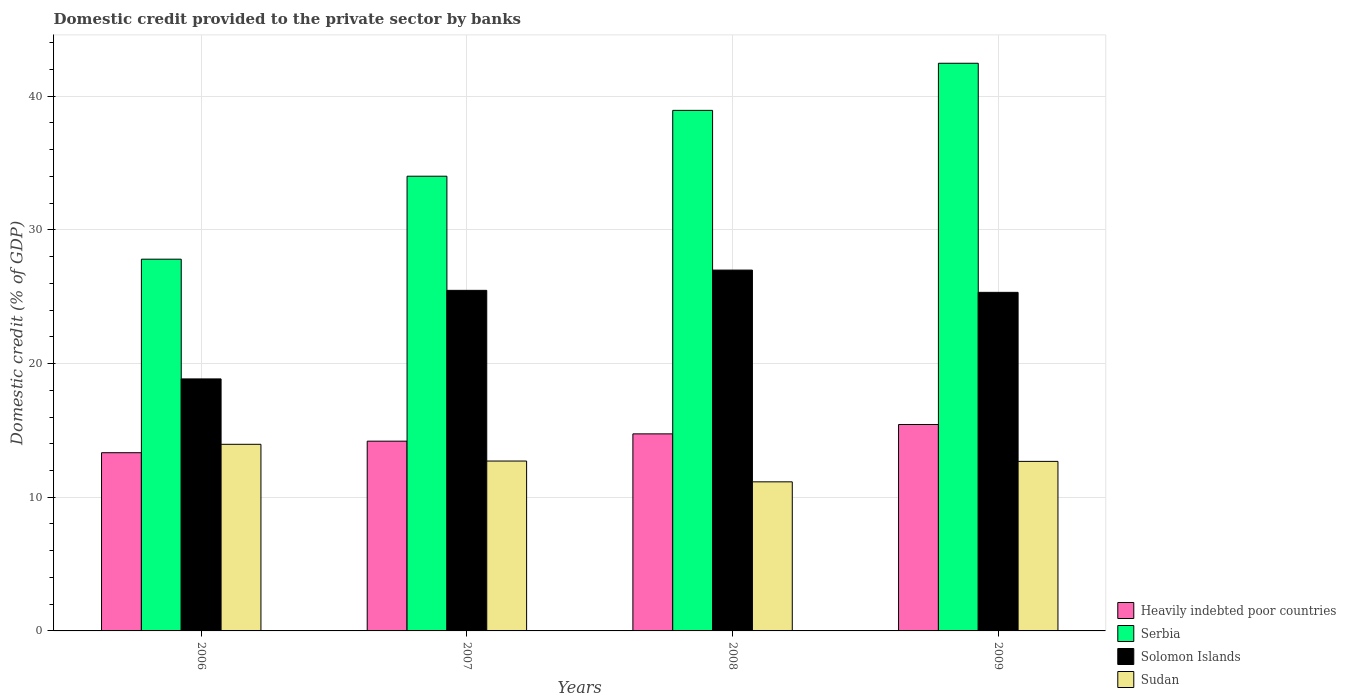How many groups of bars are there?
Provide a succinct answer. 4. How many bars are there on the 1st tick from the left?
Ensure brevity in your answer.  4. What is the label of the 2nd group of bars from the left?
Your answer should be very brief. 2007. In how many cases, is the number of bars for a given year not equal to the number of legend labels?
Provide a short and direct response. 0. What is the domestic credit provided to the private sector by banks in Serbia in 2006?
Ensure brevity in your answer.  27.81. Across all years, what is the maximum domestic credit provided to the private sector by banks in Sudan?
Keep it short and to the point. 13.96. Across all years, what is the minimum domestic credit provided to the private sector by banks in Sudan?
Make the answer very short. 11.15. In which year was the domestic credit provided to the private sector by banks in Serbia minimum?
Give a very brief answer. 2006. What is the total domestic credit provided to the private sector by banks in Sudan in the graph?
Ensure brevity in your answer.  50.5. What is the difference between the domestic credit provided to the private sector by banks in Heavily indebted poor countries in 2006 and that in 2008?
Provide a succinct answer. -1.41. What is the difference between the domestic credit provided to the private sector by banks in Sudan in 2008 and the domestic credit provided to the private sector by banks in Solomon Islands in 2009?
Give a very brief answer. -14.17. What is the average domestic credit provided to the private sector by banks in Heavily indebted poor countries per year?
Make the answer very short. 14.43. In the year 2009, what is the difference between the domestic credit provided to the private sector by banks in Solomon Islands and domestic credit provided to the private sector by banks in Heavily indebted poor countries?
Offer a very short reply. 9.89. In how many years, is the domestic credit provided to the private sector by banks in Serbia greater than 10 %?
Give a very brief answer. 4. What is the ratio of the domestic credit provided to the private sector by banks in Solomon Islands in 2006 to that in 2007?
Offer a terse response. 0.74. Is the difference between the domestic credit provided to the private sector by banks in Solomon Islands in 2006 and 2008 greater than the difference between the domestic credit provided to the private sector by banks in Heavily indebted poor countries in 2006 and 2008?
Give a very brief answer. No. What is the difference between the highest and the second highest domestic credit provided to the private sector by banks in Solomon Islands?
Provide a short and direct response. 1.52. What is the difference between the highest and the lowest domestic credit provided to the private sector by banks in Serbia?
Your response must be concise. 14.66. What does the 1st bar from the left in 2009 represents?
Offer a terse response. Heavily indebted poor countries. What does the 4th bar from the right in 2009 represents?
Offer a very short reply. Heavily indebted poor countries. How many bars are there?
Your answer should be compact. 16. Are all the bars in the graph horizontal?
Ensure brevity in your answer.  No. How many years are there in the graph?
Your response must be concise. 4. Are the values on the major ticks of Y-axis written in scientific E-notation?
Ensure brevity in your answer.  No. Does the graph contain grids?
Offer a very short reply. Yes. Where does the legend appear in the graph?
Offer a terse response. Bottom right. How are the legend labels stacked?
Your response must be concise. Vertical. What is the title of the graph?
Keep it short and to the point. Domestic credit provided to the private sector by banks. Does "Estonia" appear as one of the legend labels in the graph?
Give a very brief answer. No. What is the label or title of the Y-axis?
Provide a succinct answer. Domestic credit (% of GDP). What is the Domestic credit (% of GDP) in Heavily indebted poor countries in 2006?
Provide a succinct answer. 13.33. What is the Domestic credit (% of GDP) in Serbia in 2006?
Give a very brief answer. 27.81. What is the Domestic credit (% of GDP) of Solomon Islands in 2006?
Make the answer very short. 18.85. What is the Domestic credit (% of GDP) of Sudan in 2006?
Make the answer very short. 13.96. What is the Domestic credit (% of GDP) in Heavily indebted poor countries in 2007?
Offer a very short reply. 14.19. What is the Domestic credit (% of GDP) in Serbia in 2007?
Keep it short and to the point. 34.01. What is the Domestic credit (% of GDP) in Solomon Islands in 2007?
Make the answer very short. 25.48. What is the Domestic credit (% of GDP) of Sudan in 2007?
Keep it short and to the point. 12.71. What is the Domestic credit (% of GDP) of Heavily indebted poor countries in 2008?
Keep it short and to the point. 14.74. What is the Domestic credit (% of GDP) in Serbia in 2008?
Your response must be concise. 38.94. What is the Domestic credit (% of GDP) in Solomon Islands in 2008?
Ensure brevity in your answer.  26.99. What is the Domestic credit (% of GDP) in Sudan in 2008?
Your answer should be very brief. 11.15. What is the Domestic credit (% of GDP) of Heavily indebted poor countries in 2009?
Your response must be concise. 15.44. What is the Domestic credit (% of GDP) in Serbia in 2009?
Give a very brief answer. 42.46. What is the Domestic credit (% of GDP) of Solomon Islands in 2009?
Provide a short and direct response. 25.33. What is the Domestic credit (% of GDP) in Sudan in 2009?
Your answer should be very brief. 12.68. Across all years, what is the maximum Domestic credit (% of GDP) in Heavily indebted poor countries?
Make the answer very short. 15.44. Across all years, what is the maximum Domestic credit (% of GDP) of Serbia?
Your response must be concise. 42.46. Across all years, what is the maximum Domestic credit (% of GDP) in Solomon Islands?
Provide a succinct answer. 26.99. Across all years, what is the maximum Domestic credit (% of GDP) of Sudan?
Give a very brief answer. 13.96. Across all years, what is the minimum Domestic credit (% of GDP) of Heavily indebted poor countries?
Your answer should be compact. 13.33. Across all years, what is the minimum Domestic credit (% of GDP) of Serbia?
Your answer should be compact. 27.81. Across all years, what is the minimum Domestic credit (% of GDP) in Solomon Islands?
Your answer should be very brief. 18.85. Across all years, what is the minimum Domestic credit (% of GDP) of Sudan?
Offer a terse response. 11.15. What is the total Domestic credit (% of GDP) of Heavily indebted poor countries in the graph?
Keep it short and to the point. 57.71. What is the total Domestic credit (% of GDP) of Serbia in the graph?
Your response must be concise. 143.23. What is the total Domestic credit (% of GDP) of Solomon Islands in the graph?
Your answer should be compact. 96.65. What is the total Domestic credit (% of GDP) in Sudan in the graph?
Provide a succinct answer. 50.5. What is the difference between the Domestic credit (% of GDP) of Heavily indebted poor countries in 2006 and that in 2007?
Provide a succinct answer. -0.86. What is the difference between the Domestic credit (% of GDP) of Serbia in 2006 and that in 2007?
Your response must be concise. -6.21. What is the difference between the Domestic credit (% of GDP) of Solomon Islands in 2006 and that in 2007?
Keep it short and to the point. -6.63. What is the difference between the Domestic credit (% of GDP) of Sudan in 2006 and that in 2007?
Make the answer very short. 1.25. What is the difference between the Domestic credit (% of GDP) of Heavily indebted poor countries in 2006 and that in 2008?
Your answer should be compact. -1.41. What is the difference between the Domestic credit (% of GDP) of Serbia in 2006 and that in 2008?
Make the answer very short. -11.13. What is the difference between the Domestic credit (% of GDP) in Solomon Islands in 2006 and that in 2008?
Offer a terse response. -8.14. What is the difference between the Domestic credit (% of GDP) of Sudan in 2006 and that in 2008?
Keep it short and to the point. 2.81. What is the difference between the Domestic credit (% of GDP) in Heavily indebted poor countries in 2006 and that in 2009?
Your answer should be compact. -2.11. What is the difference between the Domestic credit (% of GDP) of Serbia in 2006 and that in 2009?
Give a very brief answer. -14.66. What is the difference between the Domestic credit (% of GDP) of Solomon Islands in 2006 and that in 2009?
Offer a terse response. -6.47. What is the difference between the Domestic credit (% of GDP) of Sudan in 2006 and that in 2009?
Make the answer very short. 1.28. What is the difference between the Domestic credit (% of GDP) of Heavily indebted poor countries in 2007 and that in 2008?
Your answer should be compact. -0.55. What is the difference between the Domestic credit (% of GDP) in Serbia in 2007 and that in 2008?
Your answer should be compact. -4.93. What is the difference between the Domestic credit (% of GDP) in Solomon Islands in 2007 and that in 2008?
Give a very brief answer. -1.52. What is the difference between the Domestic credit (% of GDP) in Sudan in 2007 and that in 2008?
Provide a short and direct response. 1.56. What is the difference between the Domestic credit (% of GDP) of Heavily indebted poor countries in 2007 and that in 2009?
Provide a short and direct response. -1.25. What is the difference between the Domestic credit (% of GDP) in Serbia in 2007 and that in 2009?
Your response must be concise. -8.45. What is the difference between the Domestic credit (% of GDP) of Solomon Islands in 2007 and that in 2009?
Your answer should be very brief. 0.15. What is the difference between the Domestic credit (% of GDP) in Sudan in 2007 and that in 2009?
Your response must be concise. 0.03. What is the difference between the Domestic credit (% of GDP) of Heavily indebted poor countries in 2008 and that in 2009?
Provide a succinct answer. -0.7. What is the difference between the Domestic credit (% of GDP) of Serbia in 2008 and that in 2009?
Keep it short and to the point. -3.52. What is the difference between the Domestic credit (% of GDP) in Solomon Islands in 2008 and that in 2009?
Give a very brief answer. 1.67. What is the difference between the Domestic credit (% of GDP) of Sudan in 2008 and that in 2009?
Provide a short and direct response. -1.53. What is the difference between the Domestic credit (% of GDP) of Heavily indebted poor countries in 2006 and the Domestic credit (% of GDP) of Serbia in 2007?
Keep it short and to the point. -20.68. What is the difference between the Domestic credit (% of GDP) of Heavily indebted poor countries in 2006 and the Domestic credit (% of GDP) of Solomon Islands in 2007?
Offer a terse response. -12.15. What is the difference between the Domestic credit (% of GDP) of Heavily indebted poor countries in 2006 and the Domestic credit (% of GDP) of Sudan in 2007?
Ensure brevity in your answer.  0.62. What is the difference between the Domestic credit (% of GDP) in Serbia in 2006 and the Domestic credit (% of GDP) in Solomon Islands in 2007?
Your response must be concise. 2.33. What is the difference between the Domestic credit (% of GDP) of Serbia in 2006 and the Domestic credit (% of GDP) of Sudan in 2007?
Make the answer very short. 15.1. What is the difference between the Domestic credit (% of GDP) of Solomon Islands in 2006 and the Domestic credit (% of GDP) of Sudan in 2007?
Your response must be concise. 6.14. What is the difference between the Domestic credit (% of GDP) of Heavily indebted poor countries in 2006 and the Domestic credit (% of GDP) of Serbia in 2008?
Your answer should be very brief. -25.61. What is the difference between the Domestic credit (% of GDP) in Heavily indebted poor countries in 2006 and the Domestic credit (% of GDP) in Solomon Islands in 2008?
Provide a short and direct response. -13.66. What is the difference between the Domestic credit (% of GDP) of Heavily indebted poor countries in 2006 and the Domestic credit (% of GDP) of Sudan in 2008?
Your answer should be very brief. 2.18. What is the difference between the Domestic credit (% of GDP) of Serbia in 2006 and the Domestic credit (% of GDP) of Solomon Islands in 2008?
Your response must be concise. 0.82. What is the difference between the Domestic credit (% of GDP) of Serbia in 2006 and the Domestic credit (% of GDP) of Sudan in 2008?
Offer a terse response. 16.66. What is the difference between the Domestic credit (% of GDP) in Solomon Islands in 2006 and the Domestic credit (% of GDP) in Sudan in 2008?
Offer a terse response. 7.7. What is the difference between the Domestic credit (% of GDP) of Heavily indebted poor countries in 2006 and the Domestic credit (% of GDP) of Serbia in 2009?
Make the answer very short. -29.13. What is the difference between the Domestic credit (% of GDP) of Heavily indebted poor countries in 2006 and the Domestic credit (% of GDP) of Solomon Islands in 2009?
Your response must be concise. -11.99. What is the difference between the Domestic credit (% of GDP) of Heavily indebted poor countries in 2006 and the Domestic credit (% of GDP) of Sudan in 2009?
Offer a terse response. 0.65. What is the difference between the Domestic credit (% of GDP) in Serbia in 2006 and the Domestic credit (% of GDP) in Solomon Islands in 2009?
Provide a short and direct response. 2.48. What is the difference between the Domestic credit (% of GDP) of Serbia in 2006 and the Domestic credit (% of GDP) of Sudan in 2009?
Offer a very short reply. 15.13. What is the difference between the Domestic credit (% of GDP) of Solomon Islands in 2006 and the Domestic credit (% of GDP) of Sudan in 2009?
Your answer should be very brief. 6.17. What is the difference between the Domestic credit (% of GDP) in Heavily indebted poor countries in 2007 and the Domestic credit (% of GDP) in Serbia in 2008?
Your response must be concise. -24.75. What is the difference between the Domestic credit (% of GDP) of Heavily indebted poor countries in 2007 and the Domestic credit (% of GDP) of Solomon Islands in 2008?
Your answer should be compact. -12.8. What is the difference between the Domestic credit (% of GDP) of Heavily indebted poor countries in 2007 and the Domestic credit (% of GDP) of Sudan in 2008?
Your answer should be compact. 3.04. What is the difference between the Domestic credit (% of GDP) of Serbia in 2007 and the Domestic credit (% of GDP) of Solomon Islands in 2008?
Ensure brevity in your answer.  7.02. What is the difference between the Domestic credit (% of GDP) of Serbia in 2007 and the Domestic credit (% of GDP) of Sudan in 2008?
Offer a very short reply. 22.86. What is the difference between the Domestic credit (% of GDP) in Solomon Islands in 2007 and the Domestic credit (% of GDP) in Sudan in 2008?
Your response must be concise. 14.32. What is the difference between the Domestic credit (% of GDP) of Heavily indebted poor countries in 2007 and the Domestic credit (% of GDP) of Serbia in 2009?
Your answer should be compact. -28.27. What is the difference between the Domestic credit (% of GDP) of Heavily indebted poor countries in 2007 and the Domestic credit (% of GDP) of Solomon Islands in 2009?
Your response must be concise. -11.13. What is the difference between the Domestic credit (% of GDP) of Heavily indebted poor countries in 2007 and the Domestic credit (% of GDP) of Sudan in 2009?
Ensure brevity in your answer.  1.51. What is the difference between the Domestic credit (% of GDP) in Serbia in 2007 and the Domestic credit (% of GDP) in Solomon Islands in 2009?
Your response must be concise. 8.69. What is the difference between the Domestic credit (% of GDP) in Serbia in 2007 and the Domestic credit (% of GDP) in Sudan in 2009?
Provide a succinct answer. 21.33. What is the difference between the Domestic credit (% of GDP) of Solomon Islands in 2007 and the Domestic credit (% of GDP) of Sudan in 2009?
Give a very brief answer. 12.79. What is the difference between the Domestic credit (% of GDP) of Heavily indebted poor countries in 2008 and the Domestic credit (% of GDP) of Serbia in 2009?
Offer a very short reply. -27.72. What is the difference between the Domestic credit (% of GDP) in Heavily indebted poor countries in 2008 and the Domestic credit (% of GDP) in Solomon Islands in 2009?
Make the answer very short. -10.59. What is the difference between the Domestic credit (% of GDP) in Heavily indebted poor countries in 2008 and the Domestic credit (% of GDP) in Sudan in 2009?
Ensure brevity in your answer.  2.06. What is the difference between the Domestic credit (% of GDP) of Serbia in 2008 and the Domestic credit (% of GDP) of Solomon Islands in 2009?
Your answer should be very brief. 13.61. What is the difference between the Domestic credit (% of GDP) of Serbia in 2008 and the Domestic credit (% of GDP) of Sudan in 2009?
Offer a very short reply. 26.26. What is the difference between the Domestic credit (% of GDP) in Solomon Islands in 2008 and the Domestic credit (% of GDP) in Sudan in 2009?
Offer a very short reply. 14.31. What is the average Domestic credit (% of GDP) in Heavily indebted poor countries per year?
Offer a terse response. 14.43. What is the average Domestic credit (% of GDP) of Serbia per year?
Your response must be concise. 35.81. What is the average Domestic credit (% of GDP) of Solomon Islands per year?
Ensure brevity in your answer.  24.16. What is the average Domestic credit (% of GDP) in Sudan per year?
Your response must be concise. 12.63. In the year 2006, what is the difference between the Domestic credit (% of GDP) in Heavily indebted poor countries and Domestic credit (% of GDP) in Serbia?
Your answer should be compact. -14.48. In the year 2006, what is the difference between the Domestic credit (% of GDP) in Heavily indebted poor countries and Domestic credit (% of GDP) in Solomon Islands?
Your answer should be very brief. -5.52. In the year 2006, what is the difference between the Domestic credit (% of GDP) in Heavily indebted poor countries and Domestic credit (% of GDP) in Sudan?
Offer a terse response. -0.63. In the year 2006, what is the difference between the Domestic credit (% of GDP) in Serbia and Domestic credit (% of GDP) in Solomon Islands?
Offer a terse response. 8.96. In the year 2006, what is the difference between the Domestic credit (% of GDP) in Serbia and Domestic credit (% of GDP) in Sudan?
Your response must be concise. 13.85. In the year 2006, what is the difference between the Domestic credit (% of GDP) in Solomon Islands and Domestic credit (% of GDP) in Sudan?
Keep it short and to the point. 4.89. In the year 2007, what is the difference between the Domestic credit (% of GDP) of Heavily indebted poor countries and Domestic credit (% of GDP) of Serbia?
Your response must be concise. -19.82. In the year 2007, what is the difference between the Domestic credit (% of GDP) in Heavily indebted poor countries and Domestic credit (% of GDP) in Solomon Islands?
Provide a succinct answer. -11.28. In the year 2007, what is the difference between the Domestic credit (% of GDP) of Heavily indebted poor countries and Domestic credit (% of GDP) of Sudan?
Keep it short and to the point. 1.49. In the year 2007, what is the difference between the Domestic credit (% of GDP) of Serbia and Domestic credit (% of GDP) of Solomon Islands?
Your response must be concise. 8.54. In the year 2007, what is the difference between the Domestic credit (% of GDP) in Serbia and Domestic credit (% of GDP) in Sudan?
Your response must be concise. 21.31. In the year 2007, what is the difference between the Domestic credit (% of GDP) in Solomon Islands and Domestic credit (% of GDP) in Sudan?
Your response must be concise. 12.77. In the year 2008, what is the difference between the Domestic credit (% of GDP) of Heavily indebted poor countries and Domestic credit (% of GDP) of Serbia?
Make the answer very short. -24.2. In the year 2008, what is the difference between the Domestic credit (% of GDP) of Heavily indebted poor countries and Domestic credit (% of GDP) of Solomon Islands?
Offer a very short reply. -12.25. In the year 2008, what is the difference between the Domestic credit (% of GDP) of Heavily indebted poor countries and Domestic credit (% of GDP) of Sudan?
Offer a terse response. 3.59. In the year 2008, what is the difference between the Domestic credit (% of GDP) in Serbia and Domestic credit (% of GDP) in Solomon Islands?
Your answer should be compact. 11.95. In the year 2008, what is the difference between the Domestic credit (% of GDP) of Serbia and Domestic credit (% of GDP) of Sudan?
Provide a short and direct response. 27.79. In the year 2008, what is the difference between the Domestic credit (% of GDP) of Solomon Islands and Domestic credit (% of GDP) of Sudan?
Your answer should be very brief. 15.84. In the year 2009, what is the difference between the Domestic credit (% of GDP) of Heavily indebted poor countries and Domestic credit (% of GDP) of Serbia?
Give a very brief answer. -27.02. In the year 2009, what is the difference between the Domestic credit (% of GDP) in Heavily indebted poor countries and Domestic credit (% of GDP) in Solomon Islands?
Ensure brevity in your answer.  -9.89. In the year 2009, what is the difference between the Domestic credit (% of GDP) in Heavily indebted poor countries and Domestic credit (% of GDP) in Sudan?
Your response must be concise. 2.76. In the year 2009, what is the difference between the Domestic credit (% of GDP) of Serbia and Domestic credit (% of GDP) of Solomon Islands?
Ensure brevity in your answer.  17.14. In the year 2009, what is the difference between the Domestic credit (% of GDP) in Serbia and Domestic credit (% of GDP) in Sudan?
Your answer should be compact. 29.78. In the year 2009, what is the difference between the Domestic credit (% of GDP) of Solomon Islands and Domestic credit (% of GDP) of Sudan?
Ensure brevity in your answer.  12.64. What is the ratio of the Domestic credit (% of GDP) of Heavily indebted poor countries in 2006 to that in 2007?
Offer a terse response. 0.94. What is the ratio of the Domestic credit (% of GDP) of Serbia in 2006 to that in 2007?
Give a very brief answer. 0.82. What is the ratio of the Domestic credit (% of GDP) in Solomon Islands in 2006 to that in 2007?
Keep it short and to the point. 0.74. What is the ratio of the Domestic credit (% of GDP) of Sudan in 2006 to that in 2007?
Provide a succinct answer. 1.1. What is the ratio of the Domestic credit (% of GDP) in Heavily indebted poor countries in 2006 to that in 2008?
Offer a very short reply. 0.9. What is the ratio of the Domestic credit (% of GDP) in Serbia in 2006 to that in 2008?
Your answer should be very brief. 0.71. What is the ratio of the Domestic credit (% of GDP) in Solomon Islands in 2006 to that in 2008?
Keep it short and to the point. 0.7. What is the ratio of the Domestic credit (% of GDP) in Sudan in 2006 to that in 2008?
Offer a terse response. 1.25. What is the ratio of the Domestic credit (% of GDP) of Heavily indebted poor countries in 2006 to that in 2009?
Your response must be concise. 0.86. What is the ratio of the Domestic credit (% of GDP) in Serbia in 2006 to that in 2009?
Your answer should be compact. 0.65. What is the ratio of the Domestic credit (% of GDP) of Solomon Islands in 2006 to that in 2009?
Provide a succinct answer. 0.74. What is the ratio of the Domestic credit (% of GDP) of Sudan in 2006 to that in 2009?
Offer a very short reply. 1.1. What is the ratio of the Domestic credit (% of GDP) in Heavily indebted poor countries in 2007 to that in 2008?
Your response must be concise. 0.96. What is the ratio of the Domestic credit (% of GDP) of Serbia in 2007 to that in 2008?
Keep it short and to the point. 0.87. What is the ratio of the Domestic credit (% of GDP) of Solomon Islands in 2007 to that in 2008?
Your response must be concise. 0.94. What is the ratio of the Domestic credit (% of GDP) of Sudan in 2007 to that in 2008?
Your answer should be very brief. 1.14. What is the ratio of the Domestic credit (% of GDP) in Heavily indebted poor countries in 2007 to that in 2009?
Your response must be concise. 0.92. What is the ratio of the Domestic credit (% of GDP) in Serbia in 2007 to that in 2009?
Provide a short and direct response. 0.8. What is the ratio of the Domestic credit (% of GDP) of Solomon Islands in 2007 to that in 2009?
Provide a succinct answer. 1.01. What is the ratio of the Domestic credit (% of GDP) in Heavily indebted poor countries in 2008 to that in 2009?
Provide a succinct answer. 0.95. What is the ratio of the Domestic credit (% of GDP) in Serbia in 2008 to that in 2009?
Offer a very short reply. 0.92. What is the ratio of the Domestic credit (% of GDP) in Solomon Islands in 2008 to that in 2009?
Ensure brevity in your answer.  1.07. What is the ratio of the Domestic credit (% of GDP) in Sudan in 2008 to that in 2009?
Give a very brief answer. 0.88. What is the difference between the highest and the second highest Domestic credit (% of GDP) in Heavily indebted poor countries?
Offer a terse response. 0.7. What is the difference between the highest and the second highest Domestic credit (% of GDP) in Serbia?
Give a very brief answer. 3.52. What is the difference between the highest and the second highest Domestic credit (% of GDP) of Solomon Islands?
Keep it short and to the point. 1.52. What is the difference between the highest and the second highest Domestic credit (% of GDP) of Sudan?
Your answer should be very brief. 1.25. What is the difference between the highest and the lowest Domestic credit (% of GDP) of Heavily indebted poor countries?
Give a very brief answer. 2.11. What is the difference between the highest and the lowest Domestic credit (% of GDP) of Serbia?
Give a very brief answer. 14.66. What is the difference between the highest and the lowest Domestic credit (% of GDP) of Solomon Islands?
Your answer should be compact. 8.14. What is the difference between the highest and the lowest Domestic credit (% of GDP) of Sudan?
Provide a short and direct response. 2.81. 